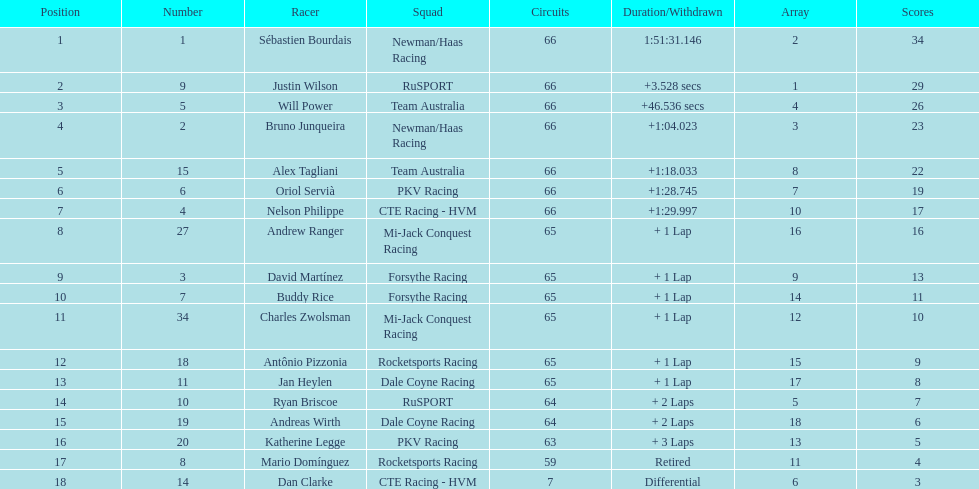At the 2006 gran premio telmex, who finished last? Dan Clarke. 